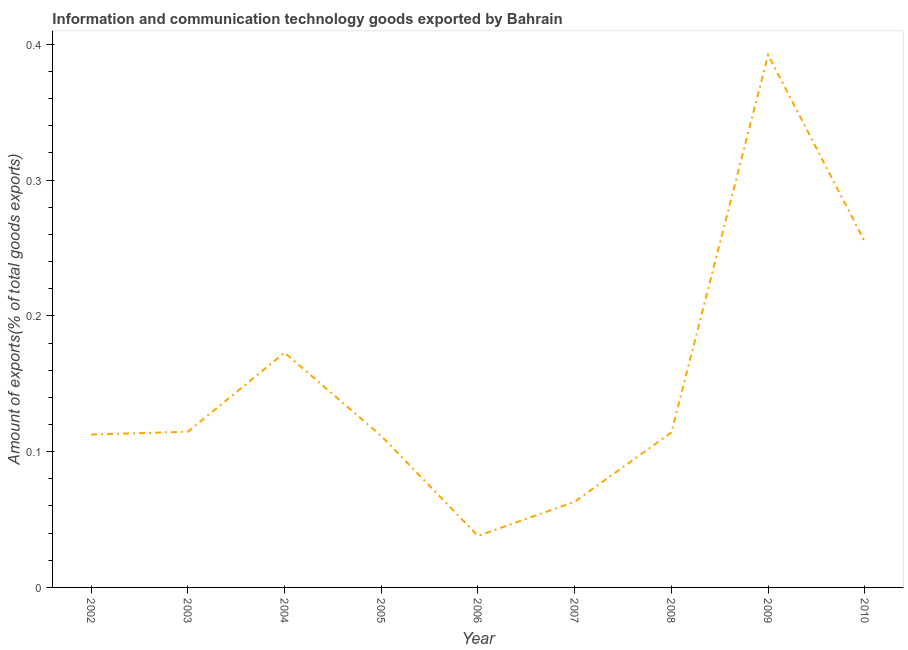What is the amount of ict goods exports in 2010?
Offer a very short reply. 0.25. Across all years, what is the maximum amount of ict goods exports?
Ensure brevity in your answer.  0.39. Across all years, what is the minimum amount of ict goods exports?
Give a very brief answer. 0.04. What is the sum of the amount of ict goods exports?
Offer a terse response. 1.37. What is the difference between the amount of ict goods exports in 2003 and 2009?
Offer a very short reply. -0.28. What is the average amount of ict goods exports per year?
Make the answer very short. 0.15. What is the median amount of ict goods exports?
Give a very brief answer. 0.11. What is the ratio of the amount of ict goods exports in 2005 to that in 2010?
Give a very brief answer. 0.44. Is the amount of ict goods exports in 2007 less than that in 2008?
Your response must be concise. Yes. Is the difference between the amount of ict goods exports in 2003 and 2010 greater than the difference between any two years?
Your answer should be compact. No. What is the difference between the highest and the second highest amount of ict goods exports?
Give a very brief answer. 0.14. What is the difference between the highest and the lowest amount of ict goods exports?
Your response must be concise. 0.35. In how many years, is the amount of ict goods exports greater than the average amount of ict goods exports taken over all years?
Your response must be concise. 3. How many years are there in the graph?
Give a very brief answer. 9. Does the graph contain grids?
Provide a succinct answer. No. What is the title of the graph?
Provide a succinct answer. Information and communication technology goods exported by Bahrain. What is the label or title of the Y-axis?
Make the answer very short. Amount of exports(% of total goods exports). What is the Amount of exports(% of total goods exports) of 2002?
Ensure brevity in your answer.  0.11. What is the Amount of exports(% of total goods exports) in 2003?
Your answer should be compact. 0.11. What is the Amount of exports(% of total goods exports) of 2004?
Your answer should be compact. 0.17. What is the Amount of exports(% of total goods exports) in 2005?
Keep it short and to the point. 0.11. What is the Amount of exports(% of total goods exports) in 2006?
Ensure brevity in your answer.  0.04. What is the Amount of exports(% of total goods exports) in 2007?
Provide a succinct answer. 0.06. What is the Amount of exports(% of total goods exports) of 2008?
Provide a short and direct response. 0.11. What is the Amount of exports(% of total goods exports) in 2009?
Your response must be concise. 0.39. What is the Amount of exports(% of total goods exports) of 2010?
Offer a terse response. 0.25. What is the difference between the Amount of exports(% of total goods exports) in 2002 and 2003?
Provide a succinct answer. -0. What is the difference between the Amount of exports(% of total goods exports) in 2002 and 2004?
Provide a short and direct response. -0.06. What is the difference between the Amount of exports(% of total goods exports) in 2002 and 2005?
Your response must be concise. 0. What is the difference between the Amount of exports(% of total goods exports) in 2002 and 2006?
Your answer should be very brief. 0.07. What is the difference between the Amount of exports(% of total goods exports) in 2002 and 2007?
Give a very brief answer. 0.05. What is the difference between the Amount of exports(% of total goods exports) in 2002 and 2008?
Provide a succinct answer. -0. What is the difference between the Amount of exports(% of total goods exports) in 2002 and 2009?
Ensure brevity in your answer.  -0.28. What is the difference between the Amount of exports(% of total goods exports) in 2002 and 2010?
Your answer should be very brief. -0.14. What is the difference between the Amount of exports(% of total goods exports) in 2003 and 2004?
Offer a terse response. -0.06. What is the difference between the Amount of exports(% of total goods exports) in 2003 and 2005?
Provide a succinct answer. 0. What is the difference between the Amount of exports(% of total goods exports) in 2003 and 2006?
Your answer should be compact. 0.08. What is the difference between the Amount of exports(% of total goods exports) in 2003 and 2007?
Offer a terse response. 0.05. What is the difference between the Amount of exports(% of total goods exports) in 2003 and 2008?
Keep it short and to the point. 0. What is the difference between the Amount of exports(% of total goods exports) in 2003 and 2009?
Provide a succinct answer. -0.28. What is the difference between the Amount of exports(% of total goods exports) in 2003 and 2010?
Offer a terse response. -0.14. What is the difference between the Amount of exports(% of total goods exports) in 2004 and 2005?
Give a very brief answer. 0.06. What is the difference between the Amount of exports(% of total goods exports) in 2004 and 2006?
Your answer should be very brief. 0.13. What is the difference between the Amount of exports(% of total goods exports) in 2004 and 2007?
Provide a short and direct response. 0.11. What is the difference between the Amount of exports(% of total goods exports) in 2004 and 2008?
Make the answer very short. 0.06. What is the difference between the Amount of exports(% of total goods exports) in 2004 and 2009?
Provide a short and direct response. -0.22. What is the difference between the Amount of exports(% of total goods exports) in 2004 and 2010?
Your answer should be compact. -0.08. What is the difference between the Amount of exports(% of total goods exports) in 2005 and 2006?
Provide a succinct answer. 0.07. What is the difference between the Amount of exports(% of total goods exports) in 2005 and 2007?
Offer a terse response. 0.05. What is the difference between the Amount of exports(% of total goods exports) in 2005 and 2008?
Keep it short and to the point. -0. What is the difference between the Amount of exports(% of total goods exports) in 2005 and 2009?
Ensure brevity in your answer.  -0.28. What is the difference between the Amount of exports(% of total goods exports) in 2005 and 2010?
Provide a short and direct response. -0.14. What is the difference between the Amount of exports(% of total goods exports) in 2006 and 2007?
Provide a short and direct response. -0.03. What is the difference between the Amount of exports(% of total goods exports) in 2006 and 2008?
Your answer should be compact. -0.08. What is the difference between the Amount of exports(% of total goods exports) in 2006 and 2009?
Offer a terse response. -0.35. What is the difference between the Amount of exports(% of total goods exports) in 2006 and 2010?
Keep it short and to the point. -0.22. What is the difference between the Amount of exports(% of total goods exports) in 2007 and 2008?
Keep it short and to the point. -0.05. What is the difference between the Amount of exports(% of total goods exports) in 2007 and 2009?
Your answer should be compact. -0.33. What is the difference between the Amount of exports(% of total goods exports) in 2007 and 2010?
Ensure brevity in your answer.  -0.19. What is the difference between the Amount of exports(% of total goods exports) in 2008 and 2009?
Your answer should be very brief. -0.28. What is the difference between the Amount of exports(% of total goods exports) in 2008 and 2010?
Give a very brief answer. -0.14. What is the difference between the Amount of exports(% of total goods exports) in 2009 and 2010?
Your response must be concise. 0.14. What is the ratio of the Amount of exports(% of total goods exports) in 2002 to that in 2004?
Ensure brevity in your answer.  0.65. What is the ratio of the Amount of exports(% of total goods exports) in 2002 to that in 2006?
Provide a succinct answer. 2.97. What is the ratio of the Amount of exports(% of total goods exports) in 2002 to that in 2007?
Ensure brevity in your answer.  1.78. What is the ratio of the Amount of exports(% of total goods exports) in 2002 to that in 2009?
Give a very brief answer. 0.29. What is the ratio of the Amount of exports(% of total goods exports) in 2002 to that in 2010?
Give a very brief answer. 0.44. What is the ratio of the Amount of exports(% of total goods exports) in 2003 to that in 2004?
Offer a very short reply. 0.66. What is the ratio of the Amount of exports(% of total goods exports) in 2003 to that in 2005?
Give a very brief answer. 1.03. What is the ratio of the Amount of exports(% of total goods exports) in 2003 to that in 2006?
Provide a succinct answer. 3.02. What is the ratio of the Amount of exports(% of total goods exports) in 2003 to that in 2007?
Provide a succinct answer. 1.82. What is the ratio of the Amount of exports(% of total goods exports) in 2003 to that in 2009?
Your answer should be very brief. 0.29. What is the ratio of the Amount of exports(% of total goods exports) in 2003 to that in 2010?
Provide a succinct answer. 0.45. What is the ratio of the Amount of exports(% of total goods exports) in 2004 to that in 2005?
Your response must be concise. 1.55. What is the ratio of the Amount of exports(% of total goods exports) in 2004 to that in 2006?
Offer a terse response. 4.56. What is the ratio of the Amount of exports(% of total goods exports) in 2004 to that in 2007?
Make the answer very short. 2.74. What is the ratio of the Amount of exports(% of total goods exports) in 2004 to that in 2008?
Offer a terse response. 1.51. What is the ratio of the Amount of exports(% of total goods exports) in 2004 to that in 2009?
Offer a terse response. 0.44. What is the ratio of the Amount of exports(% of total goods exports) in 2004 to that in 2010?
Ensure brevity in your answer.  0.68. What is the ratio of the Amount of exports(% of total goods exports) in 2005 to that in 2006?
Your answer should be very brief. 2.94. What is the ratio of the Amount of exports(% of total goods exports) in 2005 to that in 2007?
Give a very brief answer. 1.77. What is the ratio of the Amount of exports(% of total goods exports) in 2005 to that in 2008?
Your response must be concise. 0.98. What is the ratio of the Amount of exports(% of total goods exports) in 2005 to that in 2009?
Offer a terse response. 0.28. What is the ratio of the Amount of exports(% of total goods exports) in 2005 to that in 2010?
Provide a succinct answer. 0.44. What is the ratio of the Amount of exports(% of total goods exports) in 2006 to that in 2007?
Make the answer very short. 0.6. What is the ratio of the Amount of exports(% of total goods exports) in 2006 to that in 2008?
Offer a very short reply. 0.33. What is the ratio of the Amount of exports(% of total goods exports) in 2006 to that in 2009?
Your response must be concise. 0.1. What is the ratio of the Amount of exports(% of total goods exports) in 2006 to that in 2010?
Provide a short and direct response. 0.15. What is the ratio of the Amount of exports(% of total goods exports) in 2007 to that in 2008?
Offer a terse response. 0.55. What is the ratio of the Amount of exports(% of total goods exports) in 2007 to that in 2009?
Your answer should be compact. 0.16. What is the ratio of the Amount of exports(% of total goods exports) in 2007 to that in 2010?
Provide a short and direct response. 0.25. What is the ratio of the Amount of exports(% of total goods exports) in 2008 to that in 2009?
Your answer should be compact. 0.29. What is the ratio of the Amount of exports(% of total goods exports) in 2008 to that in 2010?
Your answer should be compact. 0.45. What is the ratio of the Amount of exports(% of total goods exports) in 2009 to that in 2010?
Your response must be concise. 1.54. 